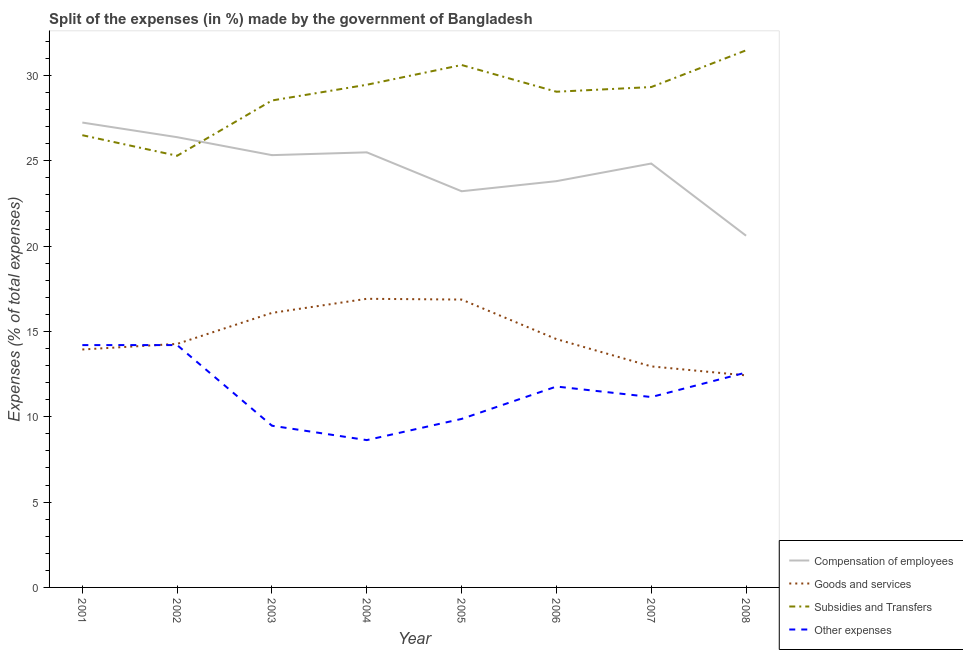How many different coloured lines are there?
Keep it short and to the point. 4. Does the line corresponding to percentage of amount spent on goods and services intersect with the line corresponding to percentage of amount spent on other expenses?
Your response must be concise. Yes. What is the percentage of amount spent on compensation of employees in 2006?
Ensure brevity in your answer.  23.81. Across all years, what is the maximum percentage of amount spent on subsidies?
Offer a very short reply. 31.47. Across all years, what is the minimum percentage of amount spent on other expenses?
Provide a succinct answer. 8.63. In which year was the percentage of amount spent on subsidies maximum?
Your response must be concise. 2008. What is the total percentage of amount spent on compensation of employees in the graph?
Keep it short and to the point. 196.91. What is the difference between the percentage of amount spent on goods and services in 2001 and that in 2008?
Keep it short and to the point. 1.52. What is the difference between the percentage of amount spent on subsidies in 2002 and the percentage of amount spent on other expenses in 2004?
Provide a short and direct response. 16.66. What is the average percentage of amount spent on compensation of employees per year?
Keep it short and to the point. 24.61. In the year 2007, what is the difference between the percentage of amount spent on other expenses and percentage of amount spent on goods and services?
Make the answer very short. -1.8. What is the ratio of the percentage of amount spent on other expenses in 2004 to that in 2005?
Ensure brevity in your answer.  0.87. What is the difference between the highest and the second highest percentage of amount spent on subsidies?
Your answer should be compact. 0.86. What is the difference between the highest and the lowest percentage of amount spent on compensation of employees?
Keep it short and to the point. 6.63. Is the sum of the percentage of amount spent on other expenses in 2003 and 2005 greater than the maximum percentage of amount spent on goods and services across all years?
Offer a very short reply. Yes. Is the percentage of amount spent on compensation of employees strictly less than the percentage of amount spent on other expenses over the years?
Provide a short and direct response. No. How many lines are there?
Your response must be concise. 4. What is the difference between two consecutive major ticks on the Y-axis?
Your answer should be compact. 5. Does the graph contain any zero values?
Ensure brevity in your answer.  No. Does the graph contain grids?
Provide a short and direct response. No. Where does the legend appear in the graph?
Make the answer very short. Bottom right. How many legend labels are there?
Make the answer very short. 4. How are the legend labels stacked?
Your response must be concise. Vertical. What is the title of the graph?
Your answer should be compact. Split of the expenses (in %) made by the government of Bangladesh. What is the label or title of the Y-axis?
Make the answer very short. Expenses (% of total expenses). What is the Expenses (% of total expenses) in Compensation of employees in 2001?
Ensure brevity in your answer.  27.24. What is the Expenses (% of total expenses) of Goods and services in 2001?
Give a very brief answer. 13.94. What is the Expenses (% of total expenses) in Subsidies and Transfers in 2001?
Make the answer very short. 26.5. What is the Expenses (% of total expenses) in Other expenses in 2001?
Offer a very short reply. 14.2. What is the Expenses (% of total expenses) in Compensation of employees in 2002?
Give a very brief answer. 26.38. What is the Expenses (% of total expenses) of Goods and services in 2002?
Provide a short and direct response. 14.27. What is the Expenses (% of total expenses) of Subsidies and Transfers in 2002?
Offer a very short reply. 25.29. What is the Expenses (% of total expenses) of Other expenses in 2002?
Your answer should be very brief. 14.2. What is the Expenses (% of total expenses) in Compensation of employees in 2003?
Give a very brief answer. 25.33. What is the Expenses (% of total expenses) of Goods and services in 2003?
Your answer should be very brief. 16.09. What is the Expenses (% of total expenses) of Subsidies and Transfers in 2003?
Offer a terse response. 28.53. What is the Expenses (% of total expenses) of Other expenses in 2003?
Keep it short and to the point. 9.48. What is the Expenses (% of total expenses) of Compensation of employees in 2004?
Offer a terse response. 25.49. What is the Expenses (% of total expenses) in Goods and services in 2004?
Offer a very short reply. 16.91. What is the Expenses (% of total expenses) of Subsidies and Transfers in 2004?
Give a very brief answer. 29.45. What is the Expenses (% of total expenses) in Other expenses in 2004?
Your answer should be compact. 8.63. What is the Expenses (% of total expenses) of Compensation of employees in 2005?
Your answer should be compact. 23.21. What is the Expenses (% of total expenses) of Goods and services in 2005?
Provide a short and direct response. 16.87. What is the Expenses (% of total expenses) in Subsidies and Transfers in 2005?
Provide a short and direct response. 30.61. What is the Expenses (% of total expenses) in Other expenses in 2005?
Make the answer very short. 9.87. What is the Expenses (% of total expenses) of Compensation of employees in 2006?
Provide a short and direct response. 23.81. What is the Expenses (% of total expenses) of Goods and services in 2006?
Give a very brief answer. 14.55. What is the Expenses (% of total expenses) in Subsidies and Transfers in 2006?
Provide a short and direct response. 29.05. What is the Expenses (% of total expenses) of Other expenses in 2006?
Your response must be concise. 11.77. What is the Expenses (% of total expenses) in Compensation of employees in 2007?
Offer a very short reply. 24.84. What is the Expenses (% of total expenses) of Goods and services in 2007?
Give a very brief answer. 12.95. What is the Expenses (% of total expenses) of Subsidies and Transfers in 2007?
Offer a very short reply. 29.32. What is the Expenses (% of total expenses) in Other expenses in 2007?
Offer a very short reply. 11.16. What is the Expenses (% of total expenses) in Compensation of employees in 2008?
Provide a short and direct response. 20.61. What is the Expenses (% of total expenses) in Goods and services in 2008?
Your response must be concise. 12.42. What is the Expenses (% of total expenses) in Subsidies and Transfers in 2008?
Offer a terse response. 31.47. What is the Expenses (% of total expenses) of Other expenses in 2008?
Your answer should be very brief. 12.59. Across all years, what is the maximum Expenses (% of total expenses) in Compensation of employees?
Make the answer very short. 27.24. Across all years, what is the maximum Expenses (% of total expenses) in Goods and services?
Offer a very short reply. 16.91. Across all years, what is the maximum Expenses (% of total expenses) in Subsidies and Transfers?
Ensure brevity in your answer.  31.47. Across all years, what is the maximum Expenses (% of total expenses) in Other expenses?
Offer a very short reply. 14.2. Across all years, what is the minimum Expenses (% of total expenses) in Compensation of employees?
Your answer should be very brief. 20.61. Across all years, what is the minimum Expenses (% of total expenses) of Goods and services?
Your answer should be compact. 12.42. Across all years, what is the minimum Expenses (% of total expenses) in Subsidies and Transfers?
Provide a succinct answer. 25.29. Across all years, what is the minimum Expenses (% of total expenses) in Other expenses?
Make the answer very short. 8.63. What is the total Expenses (% of total expenses) of Compensation of employees in the graph?
Provide a succinct answer. 196.91. What is the total Expenses (% of total expenses) in Goods and services in the graph?
Give a very brief answer. 118. What is the total Expenses (% of total expenses) of Subsidies and Transfers in the graph?
Keep it short and to the point. 230.23. What is the total Expenses (% of total expenses) of Other expenses in the graph?
Offer a very short reply. 91.9. What is the difference between the Expenses (% of total expenses) of Compensation of employees in 2001 and that in 2002?
Offer a very short reply. 0.86. What is the difference between the Expenses (% of total expenses) of Goods and services in 2001 and that in 2002?
Make the answer very short. -0.33. What is the difference between the Expenses (% of total expenses) in Subsidies and Transfers in 2001 and that in 2002?
Provide a short and direct response. 1.21. What is the difference between the Expenses (% of total expenses) of Other expenses in 2001 and that in 2002?
Your answer should be very brief. -0. What is the difference between the Expenses (% of total expenses) of Compensation of employees in 2001 and that in 2003?
Offer a very short reply. 1.91. What is the difference between the Expenses (% of total expenses) in Goods and services in 2001 and that in 2003?
Give a very brief answer. -2.14. What is the difference between the Expenses (% of total expenses) of Subsidies and Transfers in 2001 and that in 2003?
Your answer should be compact. -2.03. What is the difference between the Expenses (% of total expenses) of Other expenses in 2001 and that in 2003?
Keep it short and to the point. 4.72. What is the difference between the Expenses (% of total expenses) in Compensation of employees in 2001 and that in 2004?
Your answer should be compact. 1.75. What is the difference between the Expenses (% of total expenses) in Goods and services in 2001 and that in 2004?
Provide a succinct answer. -2.97. What is the difference between the Expenses (% of total expenses) of Subsidies and Transfers in 2001 and that in 2004?
Keep it short and to the point. -2.95. What is the difference between the Expenses (% of total expenses) of Other expenses in 2001 and that in 2004?
Your answer should be compact. 5.57. What is the difference between the Expenses (% of total expenses) in Compensation of employees in 2001 and that in 2005?
Make the answer very short. 4.02. What is the difference between the Expenses (% of total expenses) of Goods and services in 2001 and that in 2005?
Your answer should be very brief. -2.93. What is the difference between the Expenses (% of total expenses) of Subsidies and Transfers in 2001 and that in 2005?
Your response must be concise. -4.11. What is the difference between the Expenses (% of total expenses) in Other expenses in 2001 and that in 2005?
Ensure brevity in your answer.  4.33. What is the difference between the Expenses (% of total expenses) in Compensation of employees in 2001 and that in 2006?
Keep it short and to the point. 3.43. What is the difference between the Expenses (% of total expenses) of Goods and services in 2001 and that in 2006?
Your response must be concise. -0.61. What is the difference between the Expenses (% of total expenses) in Subsidies and Transfers in 2001 and that in 2006?
Your response must be concise. -2.55. What is the difference between the Expenses (% of total expenses) in Other expenses in 2001 and that in 2006?
Ensure brevity in your answer.  2.43. What is the difference between the Expenses (% of total expenses) in Compensation of employees in 2001 and that in 2007?
Your answer should be very brief. 2.4. What is the difference between the Expenses (% of total expenses) of Subsidies and Transfers in 2001 and that in 2007?
Your answer should be compact. -2.82. What is the difference between the Expenses (% of total expenses) in Other expenses in 2001 and that in 2007?
Provide a short and direct response. 3.04. What is the difference between the Expenses (% of total expenses) in Compensation of employees in 2001 and that in 2008?
Your answer should be compact. 6.63. What is the difference between the Expenses (% of total expenses) of Goods and services in 2001 and that in 2008?
Provide a short and direct response. 1.52. What is the difference between the Expenses (% of total expenses) in Subsidies and Transfers in 2001 and that in 2008?
Your answer should be very brief. -4.97. What is the difference between the Expenses (% of total expenses) in Other expenses in 2001 and that in 2008?
Provide a succinct answer. 1.61. What is the difference between the Expenses (% of total expenses) of Compensation of employees in 2002 and that in 2003?
Offer a very short reply. 1.05. What is the difference between the Expenses (% of total expenses) in Goods and services in 2002 and that in 2003?
Make the answer very short. -1.82. What is the difference between the Expenses (% of total expenses) of Subsidies and Transfers in 2002 and that in 2003?
Make the answer very short. -3.24. What is the difference between the Expenses (% of total expenses) in Other expenses in 2002 and that in 2003?
Offer a terse response. 4.73. What is the difference between the Expenses (% of total expenses) in Compensation of employees in 2002 and that in 2004?
Your answer should be very brief. 0.89. What is the difference between the Expenses (% of total expenses) in Goods and services in 2002 and that in 2004?
Provide a succinct answer. -2.64. What is the difference between the Expenses (% of total expenses) of Subsidies and Transfers in 2002 and that in 2004?
Keep it short and to the point. -4.16. What is the difference between the Expenses (% of total expenses) of Other expenses in 2002 and that in 2004?
Provide a short and direct response. 5.57. What is the difference between the Expenses (% of total expenses) of Compensation of employees in 2002 and that in 2005?
Make the answer very short. 3.17. What is the difference between the Expenses (% of total expenses) in Goods and services in 2002 and that in 2005?
Offer a terse response. -2.6. What is the difference between the Expenses (% of total expenses) of Subsidies and Transfers in 2002 and that in 2005?
Keep it short and to the point. -5.32. What is the difference between the Expenses (% of total expenses) of Other expenses in 2002 and that in 2005?
Offer a terse response. 4.33. What is the difference between the Expenses (% of total expenses) in Compensation of employees in 2002 and that in 2006?
Ensure brevity in your answer.  2.58. What is the difference between the Expenses (% of total expenses) of Goods and services in 2002 and that in 2006?
Your response must be concise. -0.28. What is the difference between the Expenses (% of total expenses) of Subsidies and Transfers in 2002 and that in 2006?
Your answer should be compact. -3.75. What is the difference between the Expenses (% of total expenses) of Other expenses in 2002 and that in 2006?
Your response must be concise. 2.43. What is the difference between the Expenses (% of total expenses) of Compensation of employees in 2002 and that in 2007?
Give a very brief answer. 1.54. What is the difference between the Expenses (% of total expenses) in Goods and services in 2002 and that in 2007?
Provide a short and direct response. 1.32. What is the difference between the Expenses (% of total expenses) of Subsidies and Transfers in 2002 and that in 2007?
Ensure brevity in your answer.  -4.03. What is the difference between the Expenses (% of total expenses) in Other expenses in 2002 and that in 2007?
Keep it short and to the point. 3.04. What is the difference between the Expenses (% of total expenses) in Compensation of employees in 2002 and that in 2008?
Ensure brevity in your answer.  5.77. What is the difference between the Expenses (% of total expenses) of Goods and services in 2002 and that in 2008?
Give a very brief answer. 1.85. What is the difference between the Expenses (% of total expenses) in Subsidies and Transfers in 2002 and that in 2008?
Provide a short and direct response. -6.18. What is the difference between the Expenses (% of total expenses) in Other expenses in 2002 and that in 2008?
Provide a short and direct response. 1.61. What is the difference between the Expenses (% of total expenses) of Compensation of employees in 2003 and that in 2004?
Keep it short and to the point. -0.16. What is the difference between the Expenses (% of total expenses) of Goods and services in 2003 and that in 2004?
Offer a terse response. -0.83. What is the difference between the Expenses (% of total expenses) of Subsidies and Transfers in 2003 and that in 2004?
Ensure brevity in your answer.  -0.92. What is the difference between the Expenses (% of total expenses) in Other expenses in 2003 and that in 2004?
Offer a very short reply. 0.84. What is the difference between the Expenses (% of total expenses) in Compensation of employees in 2003 and that in 2005?
Keep it short and to the point. 2.12. What is the difference between the Expenses (% of total expenses) of Goods and services in 2003 and that in 2005?
Provide a succinct answer. -0.78. What is the difference between the Expenses (% of total expenses) of Subsidies and Transfers in 2003 and that in 2005?
Provide a succinct answer. -2.08. What is the difference between the Expenses (% of total expenses) in Other expenses in 2003 and that in 2005?
Provide a succinct answer. -0.4. What is the difference between the Expenses (% of total expenses) of Compensation of employees in 2003 and that in 2006?
Provide a succinct answer. 1.52. What is the difference between the Expenses (% of total expenses) in Goods and services in 2003 and that in 2006?
Provide a short and direct response. 1.54. What is the difference between the Expenses (% of total expenses) in Subsidies and Transfers in 2003 and that in 2006?
Keep it short and to the point. -0.51. What is the difference between the Expenses (% of total expenses) in Other expenses in 2003 and that in 2006?
Give a very brief answer. -2.3. What is the difference between the Expenses (% of total expenses) in Compensation of employees in 2003 and that in 2007?
Your answer should be compact. 0.49. What is the difference between the Expenses (% of total expenses) in Goods and services in 2003 and that in 2007?
Your response must be concise. 3.13. What is the difference between the Expenses (% of total expenses) in Subsidies and Transfers in 2003 and that in 2007?
Offer a very short reply. -0.79. What is the difference between the Expenses (% of total expenses) in Other expenses in 2003 and that in 2007?
Provide a short and direct response. -1.68. What is the difference between the Expenses (% of total expenses) of Compensation of employees in 2003 and that in 2008?
Provide a short and direct response. 4.72. What is the difference between the Expenses (% of total expenses) of Goods and services in 2003 and that in 2008?
Make the answer very short. 3.66. What is the difference between the Expenses (% of total expenses) of Subsidies and Transfers in 2003 and that in 2008?
Keep it short and to the point. -2.94. What is the difference between the Expenses (% of total expenses) in Other expenses in 2003 and that in 2008?
Provide a succinct answer. -3.12. What is the difference between the Expenses (% of total expenses) in Compensation of employees in 2004 and that in 2005?
Offer a very short reply. 2.28. What is the difference between the Expenses (% of total expenses) in Goods and services in 2004 and that in 2005?
Provide a short and direct response. 0.04. What is the difference between the Expenses (% of total expenses) of Subsidies and Transfers in 2004 and that in 2005?
Your answer should be very brief. -1.16. What is the difference between the Expenses (% of total expenses) in Other expenses in 2004 and that in 2005?
Keep it short and to the point. -1.24. What is the difference between the Expenses (% of total expenses) in Compensation of employees in 2004 and that in 2006?
Ensure brevity in your answer.  1.69. What is the difference between the Expenses (% of total expenses) in Goods and services in 2004 and that in 2006?
Your response must be concise. 2.36. What is the difference between the Expenses (% of total expenses) in Subsidies and Transfers in 2004 and that in 2006?
Your answer should be compact. 0.41. What is the difference between the Expenses (% of total expenses) of Other expenses in 2004 and that in 2006?
Ensure brevity in your answer.  -3.14. What is the difference between the Expenses (% of total expenses) in Compensation of employees in 2004 and that in 2007?
Your answer should be compact. 0.66. What is the difference between the Expenses (% of total expenses) in Goods and services in 2004 and that in 2007?
Provide a short and direct response. 3.96. What is the difference between the Expenses (% of total expenses) of Subsidies and Transfers in 2004 and that in 2007?
Offer a terse response. 0.13. What is the difference between the Expenses (% of total expenses) in Other expenses in 2004 and that in 2007?
Keep it short and to the point. -2.52. What is the difference between the Expenses (% of total expenses) of Compensation of employees in 2004 and that in 2008?
Provide a short and direct response. 4.89. What is the difference between the Expenses (% of total expenses) of Goods and services in 2004 and that in 2008?
Your response must be concise. 4.49. What is the difference between the Expenses (% of total expenses) in Subsidies and Transfers in 2004 and that in 2008?
Your response must be concise. -2.02. What is the difference between the Expenses (% of total expenses) of Other expenses in 2004 and that in 2008?
Your answer should be very brief. -3.96. What is the difference between the Expenses (% of total expenses) of Compensation of employees in 2005 and that in 2006?
Offer a terse response. -0.59. What is the difference between the Expenses (% of total expenses) in Goods and services in 2005 and that in 2006?
Provide a short and direct response. 2.32. What is the difference between the Expenses (% of total expenses) in Subsidies and Transfers in 2005 and that in 2006?
Keep it short and to the point. 1.57. What is the difference between the Expenses (% of total expenses) of Other expenses in 2005 and that in 2006?
Your answer should be very brief. -1.9. What is the difference between the Expenses (% of total expenses) of Compensation of employees in 2005 and that in 2007?
Your answer should be very brief. -1.62. What is the difference between the Expenses (% of total expenses) of Goods and services in 2005 and that in 2007?
Your answer should be compact. 3.92. What is the difference between the Expenses (% of total expenses) of Subsidies and Transfers in 2005 and that in 2007?
Offer a very short reply. 1.29. What is the difference between the Expenses (% of total expenses) in Other expenses in 2005 and that in 2007?
Provide a short and direct response. -1.28. What is the difference between the Expenses (% of total expenses) in Compensation of employees in 2005 and that in 2008?
Your response must be concise. 2.61. What is the difference between the Expenses (% of total expenses) in Goods and services in 2005 and that in 2008?
Offer a terse response. 4.44. What is the difference between the Expenses (% of total expenses) in Subsidies and Transfers in 2005 and that in 2008?
Make the answer very short. -0.86. What is the difference between the Expenses (% of total expenses) in Other expenses in 2005 and that in 2008?
Provide a succinct answer. -2.72. What is the difference between the Expenses (% of total expenses) in Compensation of employees in 2006 and that in 2007?
Ensure brevity in your answer.  -1.03. What is the difference between the Expenses (% of total expenses) of Goods and services in 2006 and that in 2007?
Provide a succinct answer. 1.6. What is the difference between the Expenses (% of total expenses) of Subsidies and Transfers in 2006 and that in 2007?
Ensure brevity in your answer.  -0.27. What is the difference between the Expenses (% of total expenses) in Other expenses in 2006 and that in 2007?
Offer a terse response. 0.62. What is the difference between the Expenses (% of total expenses) in Compensation of employees in 2006 and that in 2008?
Your response must be concise. 3.2. What is the difference between the Expenses (% of total expenses) in Goods and services in 2006 and that in 2008?
Your answer should be very brief. 2.12. What is the difference between the Expenses (% of total expenses) of Subsidies and Transfers in 2006 and that in 2008?
Keep it short and to the point. -2.43. What is the difference between the Expenses (% of total expenses) in Other expenses in 2006 and that in 2008?
Offer a very short reply. -0.82. What is the difference between the Expenses (% of total expenses) in Compensation of employees in 2007 and that in 2008?
Keep it short and to the point. 4.23. What is the difference between the Expenses (% of total expenses) of Goods and services in 2007 and that in 2008?
Your answer should be very brief. 0.53. What is the difference between the Expenses (% of total expenses) of Subsidies and Transfers in 2007 and that in 2008?
Offer a terse response. -2.15. What is the difference between the Expenses (% of total expenses) of Other expenses in 2007 and that in 2008?
Make the answer very short. -1.44. What is the difference between the Expenses (% of total expenses) in Compensation of employees in 2001 and the Expenses (% of total expenses) in Goods and services in 2002?
Offer a very short reply. 12.97. What is the difference between the Expenses (% of total expenses) of Compensation of employees in 2001 and the Expenses (% of total expenses) of Subsidies and Transfers in 2002?
Offer a very short reply. 1.95. What is the difference between the Expenses (% of total expenses) in Compensation of employees in 2001 and the Expenses (% of total expenses) in Other expenses in 2002?
Give a very brief answer. 13.04. What is the difference between the Expenses (% of total expenses) in Goods and services in 2001 and the Expenses (% of total expenses) in Subsidies and Transfers in 2002?
Your answer should be compact. -11.35. What is the difference between the Expenses (% of total expenses) in Goods and services in 2001 and the Expenses (% of total expenses) in Other expenses in 2002?
Give a very brief answer. -0.26. What is the difference between the Expenses (% of total expenses) of Subsidies and Transfers in 2001 and the Expenses (% of total expenses) of Other expenses in 2002?
Your response must be concise. 12.3. What is the difference between the Expenses (% of total expenses) in Compensation of employees in 2001 and the Expenses (% of total expenses) in Goods and services in 2003?
Make the answer very short. 11.15. What is the difference between the Expenses (% of total expenses) of Compensation of employees in 2001 and the Expenses (% of total expenses) of Subsidies and Transfers in 2003?
Give a very brief answer. -1.29. What is the difference between the Expenses (% of total expenses) in Compensation of employees in 2001 and the Expenses (% of total expenses) in Other expenses in 2003?
Give a very brief answer. 17.76. What is the difference between the Expenses (% of total expenses) of Goods and services in 2001 and the Expenses (% of total expenses) of Subsidies and Transfers in 2003?
Keep it short and to the point. -14.59. What is the difference between the Expenses (% of total expenses) of Goods and services in 2001 and the Expenses (% of total expenses) of Other expenses in 2003?
Your answer should be very brief. 4.47. What is the difference between the Expenses (% of total expenses) in Subsidies and Transfers in 2001 and the Expenses (% of total expenses) in Other expenses in 2003?
Provide a short and direct response. 17.02. What is the difference between the Expenses (% of total expenses) in Compensation of employees in 2001 and the Expenses (% of total expenses) in Goods and services in 2004?
Give a very brief answer. 10.33. What is the difference between the Expenses (% of total expenses) of Compensation of employees in 2001 and the Expenses (% of total expenses) of Subsidies and Transfers in 2004?
Make the answer very short. -2.21. What is the difference between the Expenses (% of total expenses) of Compensation of employees in 2001 and the Expenses (% of total expenses) of Other expenses in 2004?
Ensure brevity in your answer.  18.61. What is the difference between the Expenses (% of total expenses) of Goods and services in 2001 and the Expenses (% of total expenses) of Subsidies and Transfers in 2004?
Make the answer very short. -15.51. What is the difference between the Expenses (% of total expenses) of Goods and services in 2001 and the Expenses (% of total expenses) of Other expenses in 2004?
Give a very brief answer. 5.31. What is the difference between the Expenses (% of total expenses) in Subsidies and Transfers in 2001 and the Expenses (% of total expenses) in Other expenses in 2004?
Provide a short and direct response. 17.87. What is the difference between the Expenses (% of total expenses) in Compensation of employees in 2001 and the Expenses (% of total expenses) in Goods and services in 2005?
Ensure brevity in your answer.  10.37. What is the difference between the Expenses (% of total expenses) in Compensation of employees in 2001 and the Expenses (% of total expenses) in Subsidies and Transfers in 2005?
Make the answer very short. -3.37. What is the difference between the Expenses (% of total expenses) of Compensation of employees in 2001 and the Expenses (% of total expenses) of Other expenses in 2005?
Offer a terse response. 17.37. What is the difference between the Expenses (% of total expenses) in Goods and services in 2001 and the Expenses (% of total expenses) in Subsidies and Transfers in 2005?
Provide a short and direct response. -16.67. What is the difference between the Expenses (% of total expenses) of Goods and services in 2001 and the Expenses (% of total expenses) of Other expenses in 2005?
Give a very brief answer. 4.07. What is the difference between the Expenses (% of total expenses) of Subsidies and Transfers in 2001 and the Expenses (% of total expenses) of Other expenses in 2005?
Your answer should be very brief. 16.62. What is the difference between the Expenses (% of total expenses) in Compensation of employees in 2001 and the Expenses (% of total expenses) in Goods and services in 2006?
Ensure brevity in your answer.  12.69. What is the difference between the Expenses (% of total expenses) of Compensation of employees in 2001 and the Expenses (% of total expenses) of Subsidies and Transfers in 2006?
Ensure brevity in your answer.  -1.81. What is the difference between the Expenses (% of total expenses) in Compensation of employees in 2001 and the Expenses (% of total expenses) in Other expenses in 2006?
Your answer should be very brief. 15.47. What is the difference between the Expenses (% of total expenses) of Goods and services in 2001 and the Expenses (% of total expenses) of Subsidies and Transfers in 2006?
Your answer should be compact. -15.1. What is the difference between the Expenses (% of total expenses) of Goods and services in 2001 and the Expenses (% of total expenses) of Other expenses in 2006?
Ensure brevity in your answer.  2.17. What is the difference between the Expenses (% of total expenses) in Subsidies and Transfers in 2001 and the Expenses (% of total expenses) in Other expenses in 2006?
Offer a terse response. 14.73. What is the difference between the Expenses (% of total expenses) of Compensation of employees in 2001 and the Expenses (% of total expenses) of Goods and services in 2007?
Ensure brevity in your answer.  14.29. What is the difference between the Expenses (% of total expenses) in Compensation of employees in 2001 and the Expenses (% of total expenses) in Subsidies and Transfers in 2007?
Your response must be concise. -2.08. What is the difference between the Expenses (% of total expenses) in Compensation of employees in 2001 and the Expenses (% of total expenses) in Other expenses in 2007?
Your response must be concise. 16.08. What is the difference between the Expenses (% of total expenses) of Goods and services in 2001 and the Expenses (% of total expenses) of Subsidies and Transfers in 2007?
Offer a very short reply. -15.38. What is the difference between the Expenses (% of total expenses) of Goods and services in 2001 and the Expenses (% of total expenses) of Other expenses in 2007?
Make the answer very short. 2.79. What is the difference between the Expenses (% of total expenses) of Subsidies and Transfers in 2001 and the Expenses (% of total expenses) of Other expenses in 2007?
Your response must be concise. 15.34. What is the difference between the Expenses (% of total expenses) in Compensation of employees in 2001 and the Expenses (% of total expenses) in Goods and services in 2008?
Ensure brevity in your answer.  14.81. What is the difference between the Expenses (% of total expenses) in Compensation of employees in 2001 and the Expenses (% of total expenses) in Subsidies and Transfers in 2008?
Provide a succinct answer. -4.23. What is the difference between the Expenses (% of total expenses) of Compensation of employees in 2001 and the Expenses (% of total expenses) of Other expenses in 2008?
Provide a short and direct response. 14.65. What is the difference between the Expenses (% of total expenses) of Goods and services in 2001 and the Expenses (% of total expenses) of Subsidies and Transfers in 2008?
Ensure brevity in your answer.  -17.53. What is the difference between the Expenses (% of total expenses) of Goods and services in 2001 and the Expenses (% of total expenses) of Other expenses in 2008?
Offer a very short reply. 1.35. What is the difference between the Expenses (% of total expenses) in Subsidies and Transfers in 2001 and the Expenses (% of total expenses) in Other expenses in 2008?
Your answer should be compact. 13.91. What is the difference between the Expenses (% of total expenses) of Compensation of employees in 2002 and the Expenses (% of total expenses) of Goods and services in 2003?
Provide a short and direct response. 10.3. What is the difference between the Expenses (% of total expenses) of Compensation of employees in 2002 and the Expenses (% of total expenses) of Subsidies and Transfers in 2003?
Make the answer very short. -2.15. What is the difference between the Expenses (% of total expenses) in Compensation of employees in 2002 and the Expenses (% of total expenses) in Other expenses in 2003?
Offer a terse response. 16.91. What is the difference between the Expenses (% of total expenses) of Goods and services in 2002 and the Expenses (% of total expenses) of Subsidies and Transfers in 2003?
Offer a very short reply. -14.26. What is the difference between the Expenses (% of total expenses) in Goods and services in 2002 and the Expenses (% of total expenses) in Other expenses in 2003?
Give a very brief answer. 4.79. What is the difference between the Expenses (% of total expenses) of Subsidies and Transfers in 2002 and the Expenses (% of total expenses) of Other expenses in 2003?
Your answer should be compact. 15.82. What is the difference between the Expenses (% of total expenses) of Compensation of employees in 2002 and the Expenses (% of total expenses) of Goods and services in 2004?
Provide a succinct answer. 9.47. What is the difference between the Expenses (% of total expenses) in Compensation of employees in 2002 and the Expenses (% of total expenses) in Subsidies and Transfers in 2004?
Give a very brief answer. -3.07. What is the difference between the Expenses (% of total expenses) in Compensation of employees in 2002 and the Expenses (% of total expenses) in Other expenses in 2004?
Your answer should be compact. 17.75. What is the difference between the Expenses (% of total expenses) in Goods and services in 2002 and the Expenses (% of total expenses) in Subsidies and Transfers in 2004?
Offer a terse response. -15.18. What is the difference between the Expenses (% of total expenses) of Goods and services in 2002 and the Expenses (% of total expenses) of Other expenses in 2004?
Make the answer very short. 5.64. What is the difference between the Expenses (% of total expenses) in Subsidies and Transfers in 2002 and the Expenses (% of total expenses) in Other expenses in 2004?
Ensure brevity in your answer.  16.66. What is the difference between the Expenses (% of total expenses) of Compensation of employees in 2002 and the Expenses (% of total expenses) of Goods and services in 2005?
Your answer should be compact. 9.51. What is the difference between the Expenses (% of total expenses) in Compensation of employees in 2002 and the Expenses (% of total expenses) in Subsidies and Transfers in 2005?
Offer a terse response. -4.23. What is the difference between the Expenses (% of total expenses) of Compensation of employees in 2002 and the Expenses (% of total expenses) of Other expenses in 2005?
Provide a short and direct response. 16.51. What is the difference between the Expenses (% of total expenses) in Goods and services in 2002 and the Expenses (% of total expenses) in Subsidies and Transfers in 2005?
Offer a terse response. -16.34. What is the difference between the Expenses (% of total expenses) in Goods and services in 2002 and the Expenses (% of total expenses) in Other expenses in 2005?
Your answer should be compact. 4.4. What is the difference between the Expenses (% of total expenses) of Subsidies and Transfers in 2002 and the Expenses (% of total expenses) of Other expenses in 2005?
Provide a short and direct response. 15.42. What is the difference between the Expenses (% of total expenses) in Compensation of employees in 2002 and the Expenses (% of total expenses) in Goods and services in 2006?
Your answer should be very brief. 11.83. What is the difference between the Expenses (% of total expenses) of Compensation of employees in 2002 and the Expenses (% of total expenses) of Subsidies and Transfers in 2006?
Provide a short and direct response. -2.66. What is the difference between the Expenses (% of total expenses) of Compensation of employees in 2002 and the Expenses (% of total expenses) of Other expenses in 2006?
Offer a very short reply. 14.61. What is the difference between the Expenses (% of total expenses) of Goods and services in 2002 and the Expenses (% of total expenses) of Subsidies and Transfers in 2006?
Give a very brief answer. -14.78. What is the difference between the Expenses (% of total expenses) in Goods and services in 2002 and the Expenses (% of total expenses) in Other expenses in 2006?
Give a very brief answer. 2.5. What is the difference between the Expenses (% of total expenses) of Subsidies and Transfers in 2002 and the Expenses (% of total expenses) of Other expenses in 2006?
Provide a short and direct response. 13.52. What is the difference between the Expenses (% of total expenses) in Compensation of employees in 2002 and the Expenses (% of total expenses) in Goods and services in 2007?
Your response must be concise. 13.43. What is the difference between the Expenses (% of total expenses) in Compensation of employees in 2002 and the Expenses (% of total expenses) in Subsidies and Transfers in 2007?
Offer a terse response. -2.94. What is the difference between the Expenses (% of total expenses) in Compensation of employees in 2002 and the Expenses (% of total expenses) in Other expenses in 2007?
Your answer should be compact. 15.23. What is the difference between the Expenses (% of total expenses) of Goods and services in 2002 and the Expenses (% of total expenses) of Subsidies and Transfers in 2007?
Your answer should be very brief. -15.05. What is the difference between the Expenses (% of total expenses) in Goods and services in 2002 and the Expenses (% of total expenses) in Other expenses in 2007?
Offer a terse response. 3.11. What is the difference between the Expenses (% of total expenses) in Subsidies and Transfers in 2002 and the Expenses (% of total expenses) in Other expenses in 2007?
Your response must be concise. 14.14. What is the difference between the Expenses (% of total expenses) of Compensation of employees in 2002 and the Expenses (% of total expenses) of Goods and services in 2008?
Keep it short and to the point. 13.96. What is the difference between the Expenses (% of total expenses) of Compensation of employees in 2002 and the Expenses (% of total expenses) of Subsidies and Transfers in 2008?
Provide a short and direct response. -5.09. What is the difference between the Expenses (% of total expenses) in Compensation of employees in 2002 and the Expenses (% of total expenses) in Other expenses in 2008?
Your response must be concise. 13.79. What is the difference between the Expenses (% of total expenses) of Goods and services in 2002 and the Expenses (% of total expenses) of Subsidies and Transfers in 2008?
Your answer should be compact. -17.2. What is the difference between the Expenses (% of total expenses) of Goods and services in 2002 and the Expenses (% of total expenses) of Other expenses in 2008?
Make the answer very short. 1.68. What is the difference between the Expenses (% of total expenses) of Subsidies and Transfers in 2002 and the Expenses (% of total expenses) of Other expenses in 2008?
Offer a terse response. 12.7. What is the difference between the Expenses (% of total expenses) in Compensation of employees in 2003 and the Expenses (% of total expenses) in Goods and services in 2004?
Give a very brief answer. 8.42. What is the difference between the Expenses (% of total expenses) of Compensation of employees in 2003 and the Expenses (% of total expenses) of Subsidies and Transfers in 2004?
Ensure brevity in your answer.  -4.12. What is the difference between the Expenses (% of total expenses) in Compensation of employees in 2003 and the Expenses (% of total expenses) in Other expenses in 2004?
Make the answer very short. 16.7. What is the difference between the Expenses (% of total expenses) of Goods and services in 2003 and the Expenses (% of total expenses) of Subsidies and Transfers in 2004?
Give a very brief answer. -13.37. What is the difference between the Expenses (% of total expenses) in Goods and services in 2003 and the Expenses (% of total expenses) in Other expenses in 2004?
Offer a terse response. 7.45. What is the difference between the Expenses (% of total expenses) of Subsidies and Transfers in 2003 and the Expenses (% of total expenses) of Other expenses in 2004?
Give a very brief answer. 19.9. What is the difference between the Expenses (% of total expenses) of Compensation of employees in 2003 and the Expenses (% of total expenses) of Goods and services in 2005?
Provide a succinct answer. 8.46. What is the difference between the Expenses (% of total expenses) of Compensation of employees in 2003 and the Expenses (% of total expenses) of Subsidies and Transfers in 2005?
Ensure brevity in your answer.  -5.28. What is the difference between the Expenses (% of total expenses) of Compensation of employees in 2003 and the Expenses (% of total expenses) of Other expenses in 2005?
Give a very brief answer. 15.46. What is the difference between the Expenses (% of total expenses) in Goods and services in 2003 and the Expenses (% of total expenses) in Subsidies and Transfers in 2005?
Offer a very short reply. -14.53. What is the difference between the Expenses (% of total expenses) in Goods and services in 2003 and the Expenses (% of total expenses) in Other expenses in 2005?
Offer a terse response. 6.21. What is the difference between the Expenses (% of total expenses) in Subsidies and Transfers in 2003 and the Expenses (% of total expenses) in Other expenses in 2005?
Provide a succinct answer. 18.66. What is the difference between the Expenses (% of total expenses) in Compensation of employees in 2003 and the Expenses (% of total expenses) in Goods and services in 2006?
Your answer should be compact. 10.78. What is the difference between the Expenses (% of total expenses) in Compensation of employees in 2003 and the Expenses (% of total expenses) in Subsidies and Transfers in 2006?
Your response must be concise. -3.72. What is the difference between the Expenses (% of total expenses) of Compensation of employees in 2003 and the Expenses (% of total expenses) of Other expenses in 2006?
Your response must be concise. 13.56. What is the difference between the Expenses (% of total expenses) of Goods and services in 2003 and the Expenses (% of total expenses) of Subsidies and Transfers in 2006?
Offer a very short reply. -12.96. What is the difference between the Expenses (% of total expenses) of Goods and services in 2003 and the Expenses (% of total expenses) of Other expenses in 2006?
Your answer should be very brief. 4.32. What is the difference between the Expenses (% of total expenses) of Subsidies and Transfers in 2003 and the Expenses (% of total expenses) of Other expenses in 2006?
Your response must be concise. 16.76. What is the difference between the Expenses (% of total expenses) of Compensation of employees in 2003 and the Expenses (% of total expenses) of Goods and services in 2007?
Provide a succinct answer. 12.38. What is the difference between the Expenses (% of total expenses) in Compensation of employees in 2003 and the Expenses (% of total expenses) in Subsidies and Transfers in 2007?
Give a very brief answer. -3.99. What is the difference between the Expenses (% of total expenses) of Compensation of employees in 2003 and the Expenses (% of total expenses) of Other expenses in 2007?
Your answer should be very brief. 14.17. What is the difference between the Expenses (% of total expenses) in Goods and services in 2003 and the Expenses (% of total expenses) in Subsidies and Transfers in 2007?
Provide a short and direct response. -13.23. What is the difference between the Expenses (% of total expenses) of Goods and services in 2003 and the Expenses (% of total expenses) of Other expenses in 2007?
Ensure brevity in your answer.  4.93. What is the difference between the Expenses (% of total expenses) of Subsidies and Transfers in 2003 and the Expenses (% of total expenses) of Other expenses in 2007?
Provide a short and direct response. 17.38. What is the difference between the Expenses (% of total expenses) of Compensation of employees in 2003 and the Expenses (% of total expenses) of Goods and services in 2008?
Your answer should be very brief. 12.91. What is the difference between the Expenses (% of total expenses) in Compensation of employees in 2003 and the Expenses (% of total expenses) in Subsidies and Transfers in 2008?
Provide a short and direct response. -6.14. What is the difference between the Expenses (% of total expenses) of Compensation of employees in 2003 and the Expenses (% of total expenses) of Other expenses in 2008?
Offer a terse response. 12.74. What is the difference between the Expenses (% of total expenses) of Goods and services in 2003 and the Expenses (% of total expenses) of Subsidies and Transfers in 2008?
Keep it short and to the point. -15.39. What is the difference between the Expenses (% of total expenses) in Goods and services in 2003 and the Expenses (% of total expenses) in Other expenses in 2008?
Your answer should be compact. 3.5. What is the difference between the Expenses (% of total expenses) of Subsidies and Transfers in 2003 and the Expenses (% of total expenses) of Other expenses in 2008?
Make the answer very short. 15.94. What is the difference between the Expenses (% of total expenses) in Compensation of employees in 2004 and the Expenses (% of total expenses) in Goods and services in 2005?
Make the answer very short. 8.63. What is the difference between the Expenses (% of total expenses) in Compensation of employees in 2004 and the Expenses (% of total expenses) in Subsidies and Transfers in 2005?
Give a very brief answer. -5.12. What is the difference between the Expenses (% of total expenses) of Compensation of employees in 2004 and the Expenses (% of total expenses) of Other expenses in 2005?
Provide a succinct answer. 15.62. What is the difference between the Expenses (% of total expenses) of Goods and services in 2004 and the Expenses (% of total expenses) of Subsidies and Transfers in 2005?
Your answer should be compact. -13.7. What is the difference between the Expenses (% of total expenses) in Goods and services in 2004 and the Expenses (% of total expenses) in Other expenses in 2005?
Provide a succinct answer. 7.04. What is the difference between the Expenses (% of total expenses) of Subsidies and Transfers in 2004 and the Expenses (% of total expenses) of Other expenses in 2005?
Provide a short and direct response. 19.58. What is the difference between the Expenses (% of total expenses) of Compensation of employees in 2004 and the Expenses (% of total expenses) of Goods and services in 2006?
Give a very brief answer. 10.94. What is the difference between the Expenses (% of total expenses) in Compensation of employees in 2004 and the Expenses (% of total expenses) in Subsidies and Transfers in 2006?
Offer a very short reply. -3.55. What is the difference between the Expenses (% of total expenses) of Compensation of employees in 2004 and the Expenses (% of total expenses) of Other expenses in 2006?
Ensure brevity in your answer.  13.72. What is the difference between the Expenses (% of total expenses) of Goods and services in 2004 and the Expenses (% of total expenses) of Subsidies and Transfers in 2006?
Offer a terse response. -12.13. What is the difference between the Expenses (% of total expenses) of Goods and services in 2004 and the Expenses (% of total expenses) of Other expenses in 2006?
Your response must be concise. 5.14. What is the difference between the Expenses (% of total expenses) of Subsidies and Transfers in 2004 and the Expenses (% of total expenses) of Other expenses in 2006?
Keep it short and to the point. 17.68. What is the difference between the Expenses (% of total expenses) in Compensation of employees in 2004 and the Expenses (% of total expenses) in Goods and services in 2007?
Make the answer very short. 12.54. What is the difference between the Expenses (% of total expenses) in Compensation of employees in 2004 and the Expenses (% of total expenses) in Subsidies and Transfers in 2007?
Ensure brevity in your answer.  -3.83. What is the difference between the Expenses (% of total expenses) in Compensation of employees in 2004 and the Expenses (% of total expenses) in Other expenses in 2007?
Your answer should be very brief. 14.34. What is the difference between the Expenses (% of total expenses) in Goods and services in 2004 and the Expenses (% of total expenses) in Subsidies and Transfers in 2007?
Keep it short and to the point. -12.41. What is the difference between the Expenses (% of total expenses) of Goods and services in 2004 and the Expenses (% of total expenses) of Other expenses in 2007?
Your answer should be compact. 5.76. What is the difference between the Expenses (% of total expenses) of Subsidies and Transfers in 2004 and the Expenses (% of total expenses) of Other expenses in 2007?
Your answer should be very brief. 18.3. What is the difference between the Expenses (% of total expenses) in Compensation of employees in 2004 and the Expenses (% of total expenses) in Goods and services in 2008?
Your response must be concise. 13.07. What is the difference between the Expenses (% of total expenses) in Compensation of employees in 2004 and the Expenses (% of total expenses) in Subsidies and Transfers in 2008?
Give a very brief answer. -5.98. What is the difference between the Expenses (% of total expenses) in Compensation of employees in 2004 and the Expenses (% of total expenses) in Other expenses in 2008?
Provide a short and direct response. 12.9. What is the difference between the Expenses (% of total expenses) in Goods and services in 2004 and the Expenses (% of total expenses) in Subsidies and Transfers in 2008?
Provide a succinct answer. -14.56. What is the difference between the Expenses (% of total expenses) of Goods and services in 2004 and the Expenses (% of total expenses) of Other expenses in 2008?
Ensure brevity in your answer.  4.32. What is the difference between the Expenses (% of total expenses) in Subsidies and Transfers in 2004 and the Expenses (% of total expenses) in Other expenses in 2008?
Keep it short and to the point. 16.86. What is the difference between the Expenses (% of total expenses) in Compensation of employees in 2005 and the Expenses (% of total expenses) in Goods and services in 2006?
Keep it short and to the point. 8.67. What is the difference between the Expenses (% of total expenses) of Compensation of employees in 2005 and the Expenses (% of total expenses) of Subsidies and Transfers in 2006?
Offer a very short reply. -5.83. What is the difference between the Expenses (% of total expenses) in Compensation of employees in 2005 and the Expenses (% of total expenses) in Other expenses in 2006?
Provide a short and direct response. 11.44. What is the difference between the Expenses (% of total expenses) in Goods and services in 2005 and the Expenses (% of total expenses) in Subsidies and Transfers in 2006?
Offer a very short reply. -12.18. What is the difference between the Expenses (% of total expenses) of Goods and services in 2005 and the Expenses (% of total expenses) of Other expenses in 2006?
Your response must be concise. 5.1. What is the difference between the Expenses (% of total expenses) of Subsidies and Transfers in 2005 and the Expenses (% of total expenses) of Other expenses in 2006?
Offer a terse response. 18.84. What is the difference between the Expenses (% of total expenses) of Compensation of employees in 2005 and the Expenses (% of total expenses) of Goods and services in 2007?
Your response must be concise. 10.26. What is the difference between the Expenses (% of total expenses) of Compensation of employees in 2005 and the Expenses (% of total expenses) of Subsidies and Transfers in 2007?
Offer a terse response. -6.11. What is the difference between the Expenses (% of total expenses) in Compensation of employees in 2005 and the Expenses (% of total expenses) in Other expenses in 2007?
Your answer should be compact. 12.06. What is the difference between the Expenses (% of total expenses) in Goods and services in 2005 and the Expenses (% of total expenses) in Subsidies and Transfers in 2007?
Give a very brief answer. -12.45. What is the difference between the Expenses (% of total expenses) in Goods and services in 2005 and the Expenses (% of total expenses) in Other expenses in 2007?
Provide a short and direct response. 5.71. What is the difference between the Expenses (% of total expenses) in Subsidies and Transfers in 2005 and the Expenses (% of total expenses) in Other expenses in 2007?
Offer a terse response. 19.46. What is the difference between the Expenses (% of total expenses) in Compensation of employees in 2005 and the Expenses (% of total expenses) in Goods and services in 2008?
Provide a short and direct response. 10.79. What is the difference between the Expenses (% of total expenses) of Compensation of employees in 2005 and the Expenses (% of total expenses) of Subsidies and Transfers in 2008?
Offer a very short reply. -8.26. What is the difference between the Expenses (% of total expenses) in Compensation of employees in 2005 and the Expenses (% of total expenses) in Other expenses in 2008?
Offer a terse response. 10.62. What is the difference between the Expenses (% of total expenses) of Goods and services in 2005 and the Expenses (% of total expenses) of Subsidies and Transfers in 2008?
Keep it short and to the point. -14.6. What is the difference between the Expenses (% of total expenses) in Goods and services in 2005 and the Expenses (% of total expenses) in Other expenses in 2008?
Your response must be concise. 4.28. What is the difference between the Expenses (% of total expenses) in Subsidies and Transfers in 2005 and the Expenses (% of total expenses) in Other expenses in 2008?
Your answer should be very brief. 18.02. What is the difference between the Expenses (% of total expenses) in Compensation of employees in 2006 and the Expenses (% of total expenses) in Goods and services in 2007?
Offer a very short reply. 10.85. What is the difference between the Expenses (% of total expenses) in Compensation of employees in 2006 and the Expenses (% of total expenses) in Subsidies and Transfers in 2007?
Ensure brevity in your answer.  -5.51. What is the difference between the Expenses (% of total expenses) of Compensation of employees in 2006 and the Expenses (% of total expenses) of Other expenses in 2007?
Your answer should be compact. 12.65. What is the difference between the Expenses (% of total expenses) of Goods and services in 2006 and the Expenses (% of total expenses) of Subsidies and Transfers in 2007?
Give a very brief answer. -14.77. What is the difference between the Expenses (% of total expenses) of Goods and services in 2006 and the Expenses (% of total expenses) of Other expenses in 2007?
Keep it short and to the point. 3.39. What is the difference between the Expenses (% of total expenses) of Subsidies and Transfers in 2006 and the Expenses (% of total expenses) of Other expenses in 2007?
Your answer should be very brief. 17.89. What is the difference between the Expenses (% of total expenses) of Compensation of employees in 2006 and the Expenses (% of total expenses) of Goods and services in 2008?
Keep it short and to the point. 11.38. What is the difference between the Expenses (% of total expenses) in Compensation of employees in 2006 and the Expenses (% of total expenses) in Subsidies and Transfers in 2008?
Your answer should be compact. -7.67. What is the difference between the Expenses (% of total expenses) in Compensation of employees in 2006 and the Expenses (% of total expenses) in Other expenses in 2008?
Your answer should be very brief. 11.21. What is the difference between the Expenses (% of total expenses) of Goods and services in 2006 and the Expenses (% of total expenses) of Subsidies and Transfers in 2008?
Your response must be concise. -16.92. What is the difference between the Expenses (% of total expenses) of Goods and services in 2006 and the Expenses (% of total expenses) of Other expenses in 2008?
Give a very brief answer. 1.96. What is the difference between the Expenses (% of total expenses) in Subsidies and Transfers in 2006 and the Expenses (% of total expenses) in Other expenses in 2008?
Offer a terse response. 16.46. What is the difference between the Expenses (% of total expenses) of Compensation of employees in 2007 and the Expenses (% of total expenses) of Goods and services in 2008?
Ensure brevity in your answer.  12.41. What is the difference between the Expenses (% of total expenses) in Compensation of employees in 2007 and the Expenses (% of total expenses) in Subsidies and Transfers in 2008?
Ensure brevity in your answer.  -6.63. What is the difference between the Expenses (% of total expenses) in Compensation of employees in 2007 and the Expenses (% of total expenses) in Other expenses in 2008?
Your response must be concise. 12.25. What is the difference between the Expenses (% of total expenses) of Goods and services in 2007 and the Expenses (% of total expenses) of Subsidies and Transfers in 2008?
Provide a short and direct response. -18.52. What is the difference between the Expenses (% of total expenses) of Goods and services in 2007 and the Expenses (% of total expenses) of Other expenses in 2008?
Offer a very short reply. 0.36. What is the difference between the Expenses (% of total expenses) in Subsidies and Transfers in 2007 and the Expenses (% of total expenses) in Other expenses in 2008?
Make the answer very short. 16.73. What is the average Expenses (% of total expenses) in Compensation of employees per year?
Offer a very short reply. 24.61. What is the average Expenses (% of total expenses) of Goods and services per year?
Provide a succinct answer. 14.75. What is the average Expenses (% of total expenses) of Subsidies and Transfers per year?
Make the answer very short. 28.78. What is the average Expenses (% of total expenses) in Other expenses per year?
Provide a succinct answer. 11.49. In the year 2001, what is the difference between the Expenses (% of total expenses) in Compensation of employees and Expenses (% of total expenses) in Goods and services?
Keep it short and to the point. 13.3. In the year 2001, what is the difference between the Expenses (% of total expenses) in Compensation of employees and Expenses (% of total expenses) in Subsidies and Transfers?
Your response must be concise. 0.74. In the year 2001, what is the difference between the Expenses (% of total expenses) of Compensation of employees and Expenses (% of total expenses) of Other expenses?
Your answer should be compact. 13.04. In the year 2001, what is the difference between the Expenses (% of total expenses) of Goods and services and Expenses (% of total expenses) of Subsidies and Transfers?
Provide a short and direct response. -12.56. In the year 2001, what is the difference between the Expenses (% of total expenses) of Goods and services and Expenses (% of total expenses) of Other expenses?
Make the answer very short. -0.26. In the year 2001, what is the difference between the Expenses (% of total expenses) in Subsidies and Transfers and Expenses (% of total expenses) in Other expenses?
Your response must be concise. 12.3. In the year 2002, what is the difference between the Expenses (% of total expenses) of Compensation of employees and Expenses (% of total expenses) of Goods and services?
Provide a succinct answer. 12.11. In the year 2002, what is the difference between the Expenses (% of total expenses) in Compensation of employees and Expenses (% of total expenses) in Subsidies and Transfers?
Offer a very short reply. 1.09. In the year 2002, what is the difference between the Expenses (% of total expenses) of Compensation of employees and Expenses (% of total expenses) of Other expenses?
Your answer should be very brief. 12.18. In the year 2002, what is the difference between the Expenses (% of total expenses) of Goods and services and Expenses (% of total expenses) of Subsidies and Transfers?
Ensure brevity in your answer.  -11.02. In the year 2002, what is the difference between the Expenses (% of total expenses) in Goods and services and Expenses (% of total expenses) in Other expenses?
Offer a terse response. 0.07. In the year 2002, what is the difference between the Expenses (% of total expenses) in Subsidies and Transfers and Expenses (% of total expenses) in Other expenses?
Your answer should be compact. 11.09. In the year 2003, what is the difference between the Expenses (% of total expenses) of Compensation of employees and Expenses (% of total expenses) of Goods and services?
Offer a terse response. 9.24. In the year 2003, what is the difference between the Expenses (% of total expenses) in Compensation of employees and Expenses (% of total expenses) in Subsidies and Transfers?
Your answer should be compact. -3.2. In the year 2003, what is the difference between the Expenses (% of total expenses) of Compensation of employees and Expenses (% of total expenses) of Other expenses?
Offer a terse response. 15.85. In the year 2003, what is the difference between the Expenses (% of total expenses) of Goods and services and Expenses (% of total expenses) of Subsidies and Transfers?
Provide a short and direct response. -12.45. In the year 2003, what is the difference between the Expenses (% of total expenses) in Goods and services and Expenses (% of total expenses) in Other expenses?
Provide a succinct answer. 6.61. In the year 2003, what is the difference between the Expenses (% of total expenses) in Subsidies and Transfers and Expenses (% of total expenses) in Other expenses?
Keep it short and to the point. 19.06. In the year 2004, what is the difference between the Expenses (% of total expenses) of Compensation of employees and Expenses (% of total expenses) of Goods and services?
Provide a succinct answer. 8.58. In the year 2004, what is the difference between the Expenses (% of total expenses) of Compensation of employees and Expenses (% of total expenses) of Subsidies and Transfers?
Give a very brief answer. -3.96. In the year 2004, what is the difference between the Expenses (% of total expenses) of Compensation of employees and Expenses (% of total expenses) of Other expenses?
Offer a very short reply. 16.86. In the year 2004, what is the difference between the Expenses (% of total expenses) in Goods and services and Expenses (% of total expenses) in Subsidies and Transfers?
Ensure brevity in your answer.  -12.54. In the year 2004, what is the difference between the Expenses (% of total expenses) in Goods and services and Expenses (% of total expenses) in Other expenses?
Offer a terse response. 8.28. In the year 2004, what is the difference between the Expenses (% of total expenses) in Subsidies and Transfers and Expenses (% of total expenses) in Other expenses?
Offer a terse response. 20.82. In the year 2005, what is the difference between the Expenses (% of total expenses) in Compensation of employees and Expenses (% of total expenses) in Goods and services?
Give a very brief answer. 6.35. In the year 2005, what is the difference between the Expenses (% of total expenses) of Compensation of employees and Expenses (% of total expenses) of Subsidies and Transfers?
Give a very brief answer. -7.4. In the year 2005, what is the difference between the Expenses (% of total expenses) of Compensation of employees and Expenses (% of total expenses) of Other expenses?
Your response must be concise. 13.34. In the year 2005, what is the difference between the Expenses (% of total expenses) in Goods and services and Expenses (% of total expenses) in Subsidies and Transfers?
Your response must be concise. -13.74. In the year 2005, what is the difference between the Expenses (% of total expenses) in Goods and services and Expenses (% of total expenses) in Other expenses?
Give a very brief answer. 6.99. In the year 2005, what is the difference between the Expenses (% of total expenses) of Subsidies and Transfers and Expenses (% of total expenses) of Other expenses?
Your answer should be compact. 20.74. In the year 2006, what is the difference between the Expenses (% of total expenses) of Compensation of employees and Expenses (% of total expenses) of Goods and services?
Give a very brief answer. 9.26. In the year 2006, what is the difference between the Expenses (% of total expenses) in Compensation of employees and Expenses (% of total expenses) in Subsidies and Transfers?
Give a very brief answer. -5.24. In the year 2006, what is the difference between the Expenses (% of total expenses) in Compensation of employees and Expenses (% of total expenses) in Other expenses?
Keep it short and to the point. 12.03. In the year 2006, what is the difference between the Expenses (% of total expenses) in Goods and services and Expenses (% of total expenses) in Subsidies and Transfers?
Offer a very short reply. -14.5. In the year 2006, what is the difference between the Expenses (% of total expenses) in Goods and services and Expenses (% of total expenses) in Other expenses?
Give a very brief answer. 2.78. In the year 2006, what is the difference between the Expenses (% of total expenses) in Subsidies and Transfers and Expenses (% of total expenses) in Other expenses?
Your answer should be compact. 17.27. In the year 2007, what is the difference between the Expenses (% of total expenses) of Compensation of employees and Expenses (% of total expenses) of Goods and services?
Offer a terse response. 11.89. In the year 2007, what is the difference between the Expenses (% of total expenses) of Compensation of employees and Expenses (% of total expenses) of Subsidies and Transfers?
Ensure brevity in your answer.  -4.48. In the year 2007, what is the difference between the Expenses (% of total expenses) in Compensation of employees and Expenses (% of total expenses) in Other expenses?
Ensure brevity in your answer.  13.68. In the year 2007, what is the difference between the Expenses (% of total expenses) of Goods and services and Expenses (% of total expenses) of Subsidies and Transfers?
Give a very brief answer. -16.37. In the year 2007, what is the difference between the Expenses (% of total expenses) in Goods and services and Expenses (% of total expenses) in Other expenses?
Your response must be concise. 1.8. In the year 2007, what is the difference between the Expenses (% of total expenses) in Subsidies and Transfers and Expenses (% of total expenses) in Other expenses?
Keep it short and to the point. 18.16. In the year 2008, what is the difference between the Expenses (% of total expenses) in Compensation of employees and Expenses (% of total expenses) in Goods and services?
Give a very brief answer. 8.18. In the year 2008, what is the difference between the Expenses (% of total expenses) of Compensation of employees and Expenses (% of total expenses) of Subsidies and Transfers?
Offer a terse response. -10.86. In the year 2008, what is the difference between the Expenses (% of total expenses) of Compensation of employees and Expenses (% of total expenses) of Other expenses?
Your answer should be very brief. 8.02. In the year 2008, what is the difference between the Expenses (% of total expenses) in Goods and services and Expenses (% of total expenses) in Subsidies and Transfers?
Your answer should be very brief. -19.05. In the year 2008, what is the difference between the Expenses (% of total expenses) in Goods and services and Expenses (% of total expenses) in Other expenses?
Give a very brief answer. -0.17. In the year 2008, what is the difference between the Expenses (% of total expenses) of Subsidies and Transfers and Expenses (% of total expenses) of Other expenses?
Your response must be concise. 18.88. What is the ratio of the Expenses (% of total expenses) of Compensation of employees in 2001 to that in 2002?
Make the answer very short. 1.03. What is the ratio of the Expenses (% of total expenses) in Goods and services in 2001 to that in 2002?
Offer a terse response. 0.98. What is the ratio of the Expenses (% of total expenses) in Subsidies and Transfers in 2001 to that in 2002?
Provide a short and direct response. 1.05. What is the ratio of the Expenses (% of total expenses) in Other expenses in 2001 to that in 2002?
Provide a short and direct response. 1. What is the ratio of the Expenses (% of total expenses) of Compensation of employees in 2001 to that in 2003?
Provide a succinct answer. 1.08. What is the ratio of the Expenses (% of total expenses) in Goods and services in 2001 to that in 2003?
Give a very brief answer. 0.87. What is the ratio of the Expenses (% of total expenses) in Subsidies and Transfers in 2001 to that in 2003?
Your answer should be compact. 0.93. What is the ratio of the Expenses (% of total expenses) in Other expenses in 2001 to that in 2003?
Give a very brief answer. 1.5. What is the ratio of the Expenses (% of total expenses) of Compensation of employees in 2001 to that in 2004?
Provide a short and direct response. 1.07. What is the ratio of the Expenses (% of total expenses) in Goods and services in 2001 to that in 2004?
Your answer should be compact. 0.82. What is the ratio of the Expenses (% of total expenses) in Subsidies and Transfers in 2001 to that in 2004?
Ensure brevity in your answer.  0.9. What is the ratio of the Expenses (% of total expenses) of Other expenses in 2001 to that in 2004?
Provide a succinct answer. 1.64. What is the ratio of the Expenses (% of total expenses) of Compensation of employees in 2001 to that in 2005?
Your answer should be compact. 1.17. What is the ratio of the Expenses (% of total expenses) in Goods and services in 2001 to that in 2005?
Provide a succinct answer. 0.83. What is the ratio of the Expenses (% of total expenses) in Subsidies and Transfers in 2001 to that in 2005?
Offer a very short reply. 0.87. What is the ratio of the Expenses (% of total expenses) in Other expenses in 2001 to that in 2005?
Offer a terse response. 1.44. What is the ratio of the Expenses (% of total expenses) in Compensation of employees in 2001 to that in 2006?
Your answer should be compact. 1.14. What is the ratio of the Expenses (% of total expenses) of Goods and services in 2001 to that in 2006?
Ensure brevity in your answer.  0.96. What is the ratio of the Expenses (% of total expenses) in Subsidies and Transfers in 2001 to that in 2006?
Make the answer very short. 0.91. What is the ratio of the Expenses (% of total expenses) in Other expenses in 2001 to that in 2006?
Keep it short and to the point. 1.21. What is the ratio of the Expenses (% of total expenses) of Compensation of employees in 2001 to that in 2007?
Provide a succinct answer. 1.1. What is the ratio of the Expenses (% of total expenses) of Goods and services in 2001 to that in 2007?
Provide a succinct answer. 1.08. What is the ratio of the Expenses (% of total expenses) in Subsidies and Transfers in 2001 to that in 2007?
Provide a succinct answer. 0.9. What is the ratio of the Expenses (% of total expenses) in Other expenses in 2001 to that in 2007?
Ensure brevity in your answer.  1.27. What is the ratio of the Expenses (% of total expenses) in Compensation of employees in 2001 to that in 2008?
Make the answer very short. 1.32. What is the ratio of the Expenses (% of total expenses) of Goods and services in 2001 to that in 2008?
Offer a terse response. 1.12. What is the ratio of the Expenses (% of total expenses) in Subsidies and Transfers in 2001 to that in 2008?
Offer a terse response. 0.84. What is the ratio of the Expenses (% of total expenses) of Other expenses in 2001 to that in 2008?
Offer a very short reply. 1.13. What is the ratio of the Expenses (% of total expenses) in Compensation of employees in 2002 to that in 2003?
Your answer should be compact. 1.04. What is the ratio of the Expenses (% of total expenses) of Goods and services in 2002 to that in 2003?
Your response must be concise. 0.89. What is the ratio of the Expenses (% of total expenses) of Subsidies and Transfers in 2002 to that in 2003?
Provide a short and direct response. 0.89. What is the ratio of the Expenses (% of total expenses) in Other expenses in 2002 to that in 2003?
Offer a terse response. 1.5. What is the ratio of the Expenses (% of total expenses) of Compensation of employees in 2002 to that in 2004?
Provide a short and direct response. 1.03. What is the ratio of the Expenses (% of total expenses) in Goods and services in 2002 to that in 2004?
Your answer should be very brief. 0.84. What is the ratio of the Expenses (% of total expenses) of Subsidies and Transfers in 2002 to that in 2004?
Offer a terse response. 0.86. What is the ratio of the Expenses (% of total expenses) of Other expenses in 2002 to that in 2004?
Your answer should be very brief. 1.65. What is the ratio of the Expenses (% of total expenses) in Compensation of employees in 2002 to that in 2005?
Your response must be concise. 1.14. What is the ratio of the Expenses (% of total expenses) of Goods and services in 2002 to that in 2005?
Ensure brevity in your answer.  0.85. What is the ratio of the Expenses (% of total expenses) in Subsidies and Transfers in 2002 to that in 2005?
Give a very brief answer. 0.83. What is the ratio of the Expenses (% of total expenses) of Other expenses in 2002 to that in 2005?
Offer a terse response. 1.44. What is the ratio of the Expenses (% of total expenses) of Compensation of employees in 2002 to that in 2006?
Your answer should be very brief. 1.11. What is the ratio of the Expenses (% of total expenses) of Goods and services in 2002 to that in 2006?
Provide a succinct answer. 0.98. What is the ratio of the Expenses (% of total expenses) in Subsidies and Transfers in 2002 to that in 2006?
Give a very brief answer. 0.87. What is the ratio of the Expenses (% of total expenses) of Other expenses in 2002 to that in 2006?
Your response must be concise. 1.21. What is the ratio of the Expenses (% of total expenses) of Compensation of employees in 2002 to that in 2007?
Your answer should be compact. 1.06. What is the ratio of the Expenses (% of total expenses) in Goods and services in 2002 to that in 2007?
Keep it short and to the point. 1.1. What is the ratio of the Expenses (% of total expenses) in Subsidies and Transfers in 2002 to that in 2007?
Your answer should be very brief. 0.86. What is the ratio of the Expenses (% of total expenses) in Other expenses in 2002 to that in 2007?
Your response must be concise. 1.27. What is the ratio of the Expenses (% of total expenses) in Compensation of employees in 2002 to that in 2008?
Ensure brevity in your answer.  1.28. What is the ratio of the Expenses (% of total expenses) in Goods and services in 2002 to that in 2008?
Your answer should be very brief. 1.15. What is the ratio of the Expenses (% of total expenses) of Subsidies and Transfers in 2002 to that in 2008?
Your answer should be very brief. 0.8. What is the ratio of the Expenses (% of total expenses) of Other expenses in 2002 to that in 2008?
Ensure brevity in your answer.  1.13. What is the ratio of the Expenses (% of total expenses) in Compensation of employees in 2003 to that in 2004?
Offer a terse response. 0.99. What is the ratio of the Expenses (% of total expenses) in Goods and services in 2003 to that in 2004?
Provide a short and direct response. 0.95. What is the ratio of the Expenses (% of total expenses) in Subsidies and Transfers in 2003 to that in 2004?
Give a very brief answer. 0.97. What is the ratio of the Expenses (% of total expenses) in Other expenses in 2003 to that in 2004?
Offer a terse response. 1.1. What is the ratio of the Expenses (% of total expenses) of Compensation of employees in 2003 to that in 2005?
Your answer should be very brief. 1.09. What is the ratio of the Expenses (% of total expenses) in Goods and services in 2003 to that in 2005?
Your response must be concise. 0.95. What is the ratio of the Expenses (% of total expenses) in Subsidies and Transfers in 2003 to that in 2005?
Your answer should be compact. 0.93. What is the ratio of the Expenses (% of total expenses) in Other expenses in 2003 to that in 2005?
Give a very brief answer. 0.96. What is the ratio of the Expenses (% of total expenses) of Compensation of employees in 2003 to that in 2006?
Ensure brevity in your answer.  1.06. What is the ratio of the Expenses (% of total expenses) of Goods and services in 2003 to that in 2006?
Offer a very short reply. 1.11. What is the ratio of the Expenses (% of total expenses) of Subsidies and Transfers in 2003 to that in 2006?
Ensure brevity in your answer.  0.98. What is the ratio of the Expenses (% of total expenses) in Other expenses in 2003 to that in 2006?
Your answer should be compact. 0.81. What is the ratio of the Expenses (% of total expenses) in Compensation of employees in 2003 to that in 2007?
Give a very brief answer. 1.02. What is the ratio of the Expenses (% of total expenses) of Goods and services in 2003 to that in 2007?
Provide a succinct answer. 1.24. What is the ratio of the Expenses (% of total expenses) of Subsidies and Transfers in 2003 to that in 2007?
Provide a succinct answer. 0.97. What is the ratio of the Expenses (% of total expenses) of Other expenses in 2003 to that in 2007?
Offer a terse response. 0.85. What is the ratio of the Expenses (% of total expenses) of Compensation of employees in 2003 to that in 2008?
Your answer should be compact. 1.23. What is the ratio of the Expenses (% of total expenses) in Goods and services in 2003 to that in 2008?
Give a very brief answer. 1.29. What is the ratio of the Expenses (% of total expenses) in Subsidies and Transfers in 2003 to that in 2008?
Your answer should be very brief. 0.91. What is the ratio of the Expenses (% of total expenses) of Other expenses in 2003 to that in 2008?
Your answer should be very brief. 0.75. What is the ratio of the Expenses (% of total expenses) of Compensation of employees in 2004 to that in 2005?
Your response must be concise. 1.1. What is the ratio of the Expenses (% of total expenses) of Goods and services in 2004 to that in 2005?
Give a very brief answer. 1. What is the ratio of the Expenses (% of total expenses) of Subsidies and Transfers in 2004 to that in 2005?
Your answer should be very brief. 0.96. What is the ratio of the Expenses (% of total expenses) in Other expenses in 2004 to that in 2005?
Your answer should be compact. 0.87. What is the ratio of the Expenses (% of total expenses) of Compensation of employees in 2004 to that in 2006?
Provide a succinct answer. 1.07. What is the ratio of the Expenses (% of total expenses) of Goods and services in 2004 to that in 2006?
Your response must be concise. 1.16. What is the ratio of the Expenses (% of total expenses) in Subsidies and Transfers in 2004 to that in 2006?
Ensure brevity in your answer.  1.01. What is the ratio of the Expenses (% of total expenses) of Other expenses in 2004 to that in 2006?
Ensure brevity in your answer.  0.73. What is the ratio of the Expenses (% of total expenses) in Compensation of employees in 2004 to that in 2007?
Offer a terse response. 1.03. What is the ratio of the Expenses (% of total expenses) in Goods and services in 2004 to that in 2007?
Provide a short and direct response. 1.31. What is the ratio of the Expenses (% of total expenses) in Subsidies and Transfers in 2004 to that in 2007?
Offer a very short reply. 1. What is the ratio of the Expenses (% of total expenses) of Other expenses in 2004 to that in 2007?
Your answer should be very brief. 0.77. What is the ratio of the Expenses (% of total expenses) of Compensation of employees in 2004 to that in 2008?
Provide a succinct answer. 1.24. What is the ratio of the Expenses (% of total expenses) in Goods and services in 2004 to that in 2008?
Your response must be concise. 1.36. What is the ratio of the Expenses (% of total expenses) of Subsidies and Transfers in 2004 to that in 2008?
Your answer should be very brief. 0.94. What is the ratio of the Expenses (% of total expenses) in Other expenses in 2004 to that in 2008?
Offer a terse response. 0.69. What is the ratio of the Expenses (% of total expenses) of Compensation of employees in 2005 to that in 2006?
Make the answer very short. 0.98. What is the ratio of the Expenses (% of total expenses) of Goods and services in 2005 to that in 2006?
Your response must be concise. 1.16. What is the ratio of the Expenses (% of total expenses) in Subsidies and Transfers in 2005 to that in 2006?
Offer a terse response. 1.05. What is the ratio of the Expenses (% of total expenses) of Other expenses in 2005 to that in 2006?
Provide a short and direct response. 0.84. What is the ratio of the Expenses (% of total expenses) in Compensation of employees in 2005 to that in 2007?
Your answer should be very brief. 0.93. What is the ratio of the Expenses (% of total expenses) in Goods and services in 2005 to that in 2007?
Offer a terse response. 1.3. What is the ratio of the Expenses (% of total expenses) of Subsidies and Transfers in 2005 to that in 2007?
Provide a succinct answer. 1.04. What is the ratio of the Expenses (% of total expenses) of Other expenses in 2005 to that in 2007?
Give a very brief answer. 0.89. What is the ratio of the Expenses (% of total expenses) of Compensation of employees in 2005 to that in 2008?
Offer a very short reply. 1.13. What is the ratio of the Expenses (% of total expenses) in Goods and services in 2005 to that in 2008?
Your answer should be compact. 1.36. What is the ratio of the Expenses (% of total expenses) in Subsidies and Transfers in 2005 to that in 2008?
Provide a short and direct response. 0.97. What is the ratio of the Expenses (% of total expenses) of Other expenses in 2005 to that in 2008?
Offer a very short reply. 0.78. What is the ratio of the Expenses (% of total expenses) of Compensation of employees in 2006 to that in 2007?
Ensure brevity in your answer.  0.96. What is the ratio of the Expenses (% of total expenses) of Goods and services in 2006 to that in 2007?
Keep it short and to the point. 1.12. What is the ratio of the Expenses (% of total expenses) of Other expenses in 2006 to that in 2007?
Your answer should be compact. 1.06. What is the ratio of the Expenses (% of total expenses) of Compensation of employees in 2006 to that in 2008?
Your answer should be compact. 1.16. What is the ratio of the Expenses (% of total expenses) of Goods and services in 2006 to that in 2008?
Offer a very short reply. 1.17. What is the ratio of the Expenses (% of total expenses) of Subsidies and Transfers in 2006 to that in 2008?
Provide a succinct answer. 0.92. What is the ratio of the Expenses (% of total expenses) of Other expenses in 2006 to that in 2008?
Keep it short and to the point. 0.93. What is the ratio of the Expenses (% of total expenses) in Compensation of employees in 2007 to that in 2008?
Ensure brevity in your answer.  1.21. What is the ratio of the Expenses (% of total expenses) in Goods and services in 2007 to that in 2008?
Provide a succinct answer. 1.04. What is the ratio of the Expenses (% of total expenses) in Subsidies and Transfers in 2007 to that in 2008?
Make the answer very short. 0.93. What is the ratio of the Expenses (% of total expenses) in Other expenses in 2007 to that in 2008?
Offer a very short reply. 0.89. What is the difference between the highest and the second highest Expenses (% of total expenses) of Compensation of employees?
Ensure brevity in your answer.  0.86. What is the difference between the highest and the second highest Expenses (% of total expenses) of Goods and services?
Provide a succinct answer. 0.04. What is the difference between the highest and the second highest Expenses (% of total expenses) of Subsidies and Transfers?
Ensure brevity in your answer.  0.86. What is the difference between the highest and the second highest Expenses (% of total expenses) in Other expenses?
Offer a terse response. 0. What is the difference between the highest and the lowest Expenses (% of total expenses) of Compensation of employees?
Your answer should be very brief. 6.63. What is the difference between the highest and the lowest Expenses (% of total expenses) of Goods and services?
Offer a very short reply. 4.49. What is the difference between the highest and the lowest Expenses (% of total expenses) in Subsidies and Transfers?
Offer a very short reply. 6.18. What is the difference between the highest and the lowest Expenses (% of total expenses) in Other expenses?
Make the answer very short. 5.57. 